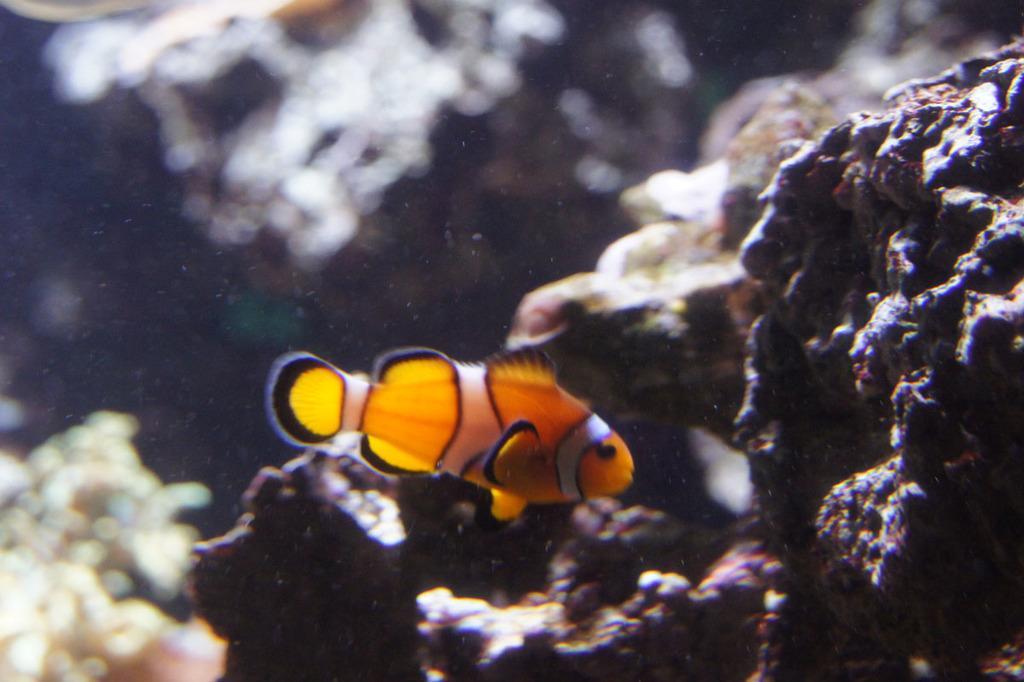In one or two sentences, can you explain what this image depicts? In this image I can see a fish in yellow and black color. Back I can see few stones and blurred background. 